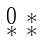<formula> <loc_0><loc_0><loc_500><loc_500>\begin{smallmatrix} 0 & * \\ * & * \end{smallmatrix}</formula> 